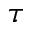<formula> <loc_0><loc_0><loc_500><loc_500>\tau</formula> 